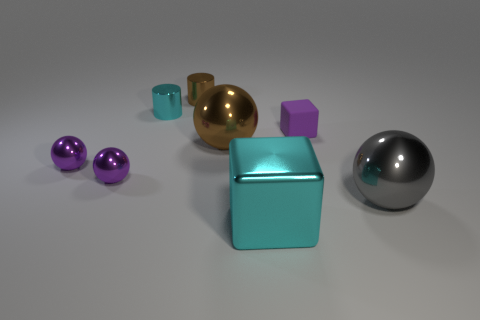Subtract all yellow balls. Subtract all blue blocks. How many balls are left? 4 Add 1 brown things. How many objects exist? 9 Subtract all cylinders. How many objects are left? 6 Add 1 large metallic things. How many large metallic things exist? 4 Subtract 0 yellow spheres. How many objects are left? 8 Subtract all gray metallic objects. Subtract all small cyan things. How many objects are left? 6 Add 3 big brown shiny things. How many big brown shiny things are left? 4 